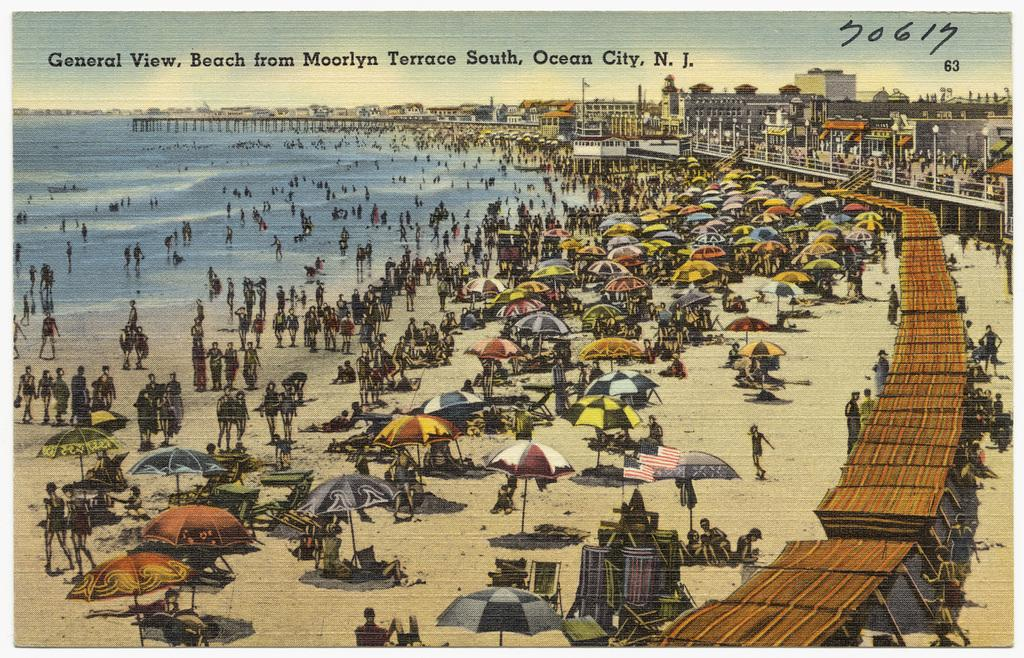<image>
Create a compact narrative representing the image presented. A painting of the beach from the Moorlyn Terrace South in Ocean City. 